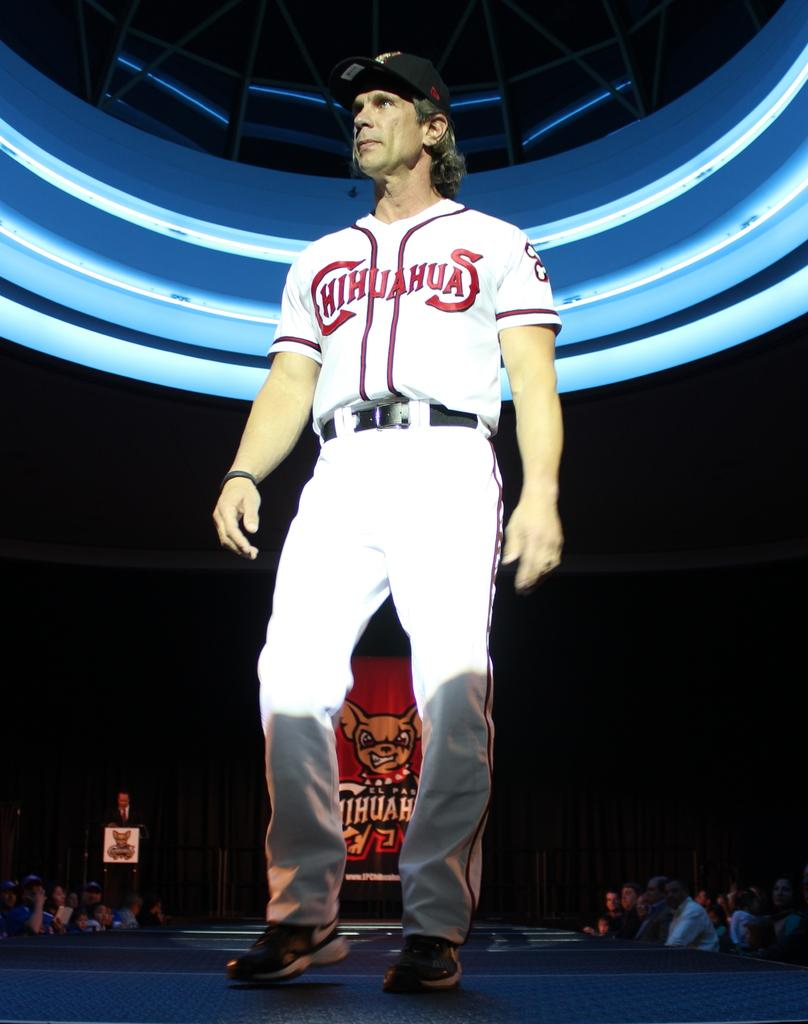<image>
Provide a brief description of the given image. A man is standing on a stage and his baseball uniform says Chihuahuas. 